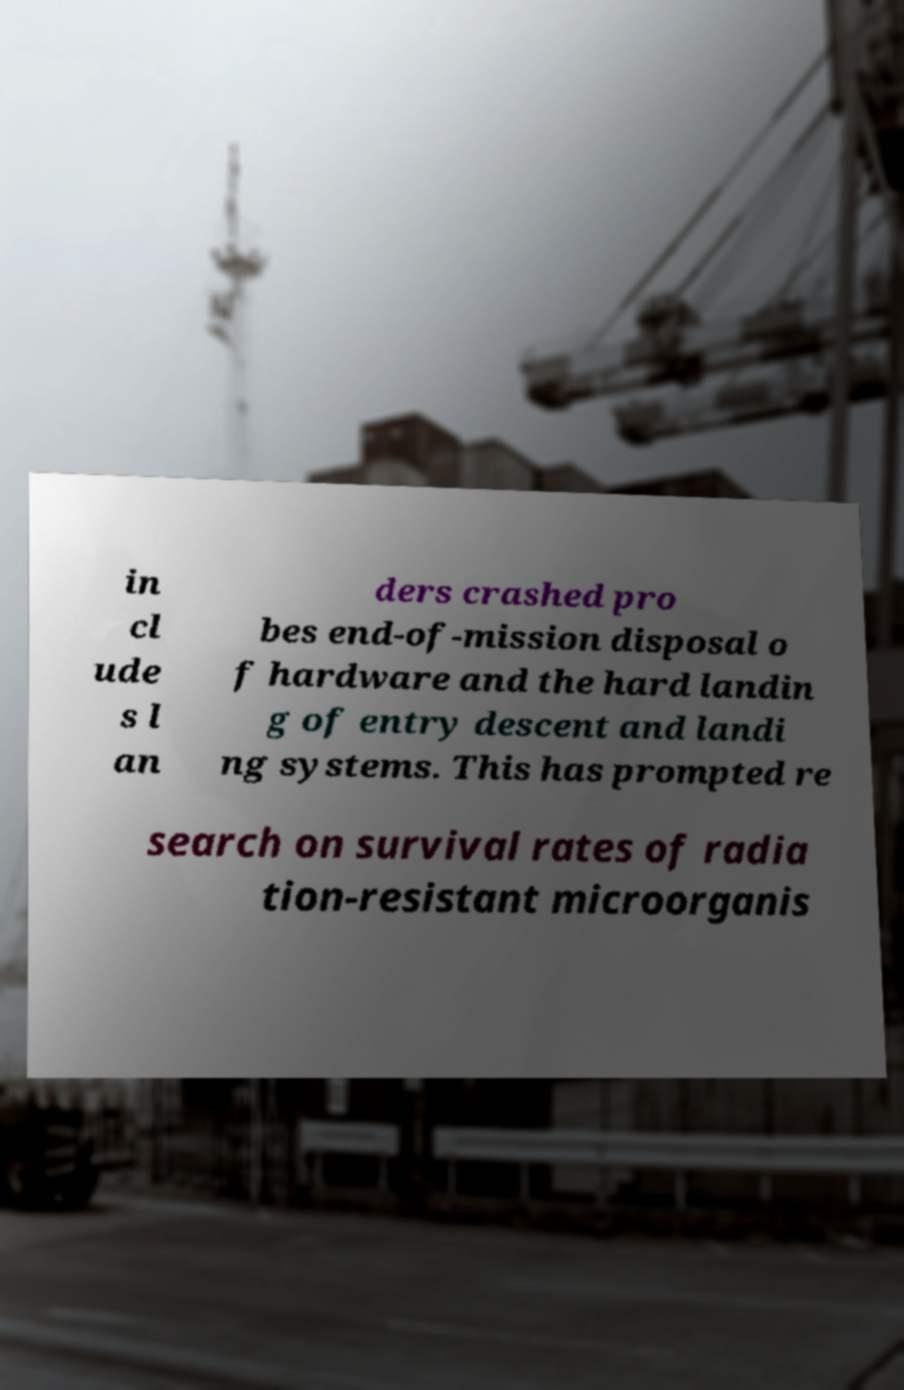Please read and relay the text visible in this image. What does it say? in cl ude s l an ders crashed pro bes end-of-mission disposal o f hardware and the hard landin g of entry descent and landi ng systems. This has prompted re search on survival rates of radia tion-resistant microorganis 